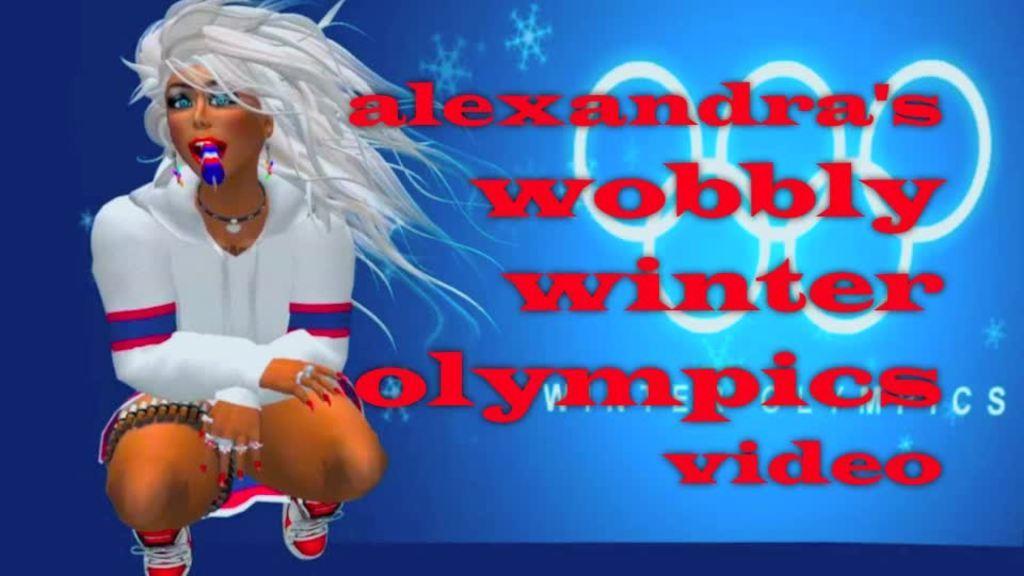In one or two sentences, can you explain what this image depicts? This is an animated image. On the left there is a person holding an object in his mouth and squatting. On the right we can see the text on the image. 